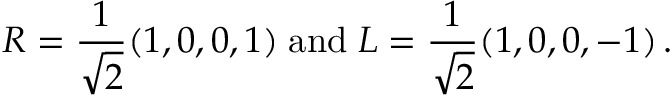<formula> <loc_0><loc_0><loc_500><loc_500>R = { \frac { 1 } { \sqrt { 2 } } } ( 1 , 0 , 0 , 1 ) \, a n d \, L = { \frac { 1 } { \sqrt { 2 } } } ( 1 , 0 , 0 , - 1 ) \, .</formula> 